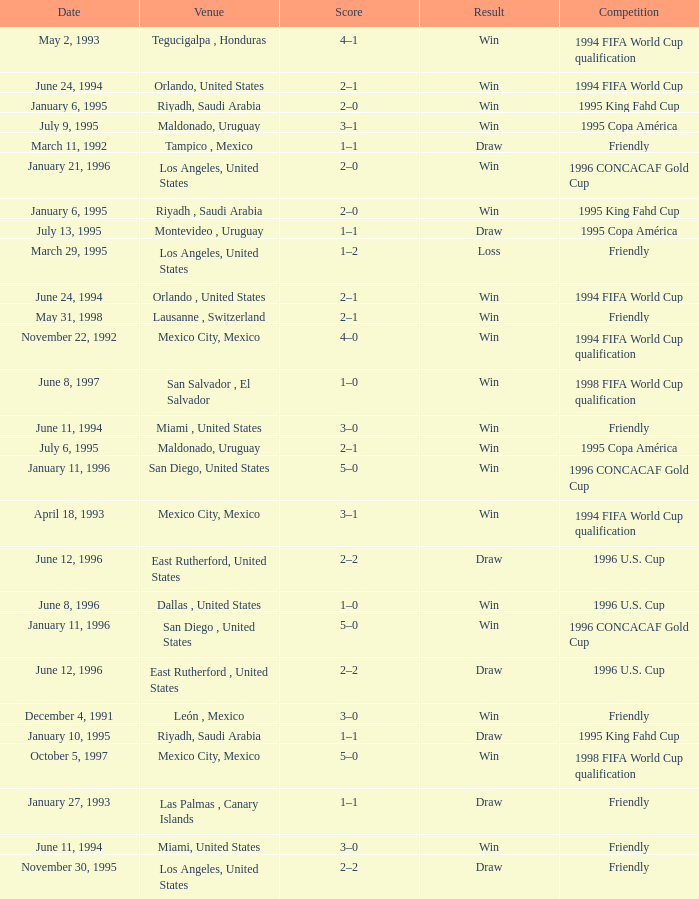What is Score, when Venue is Riyadh, Saudi Arabia, and when Result is "Win"? 2–0, 2–0. 